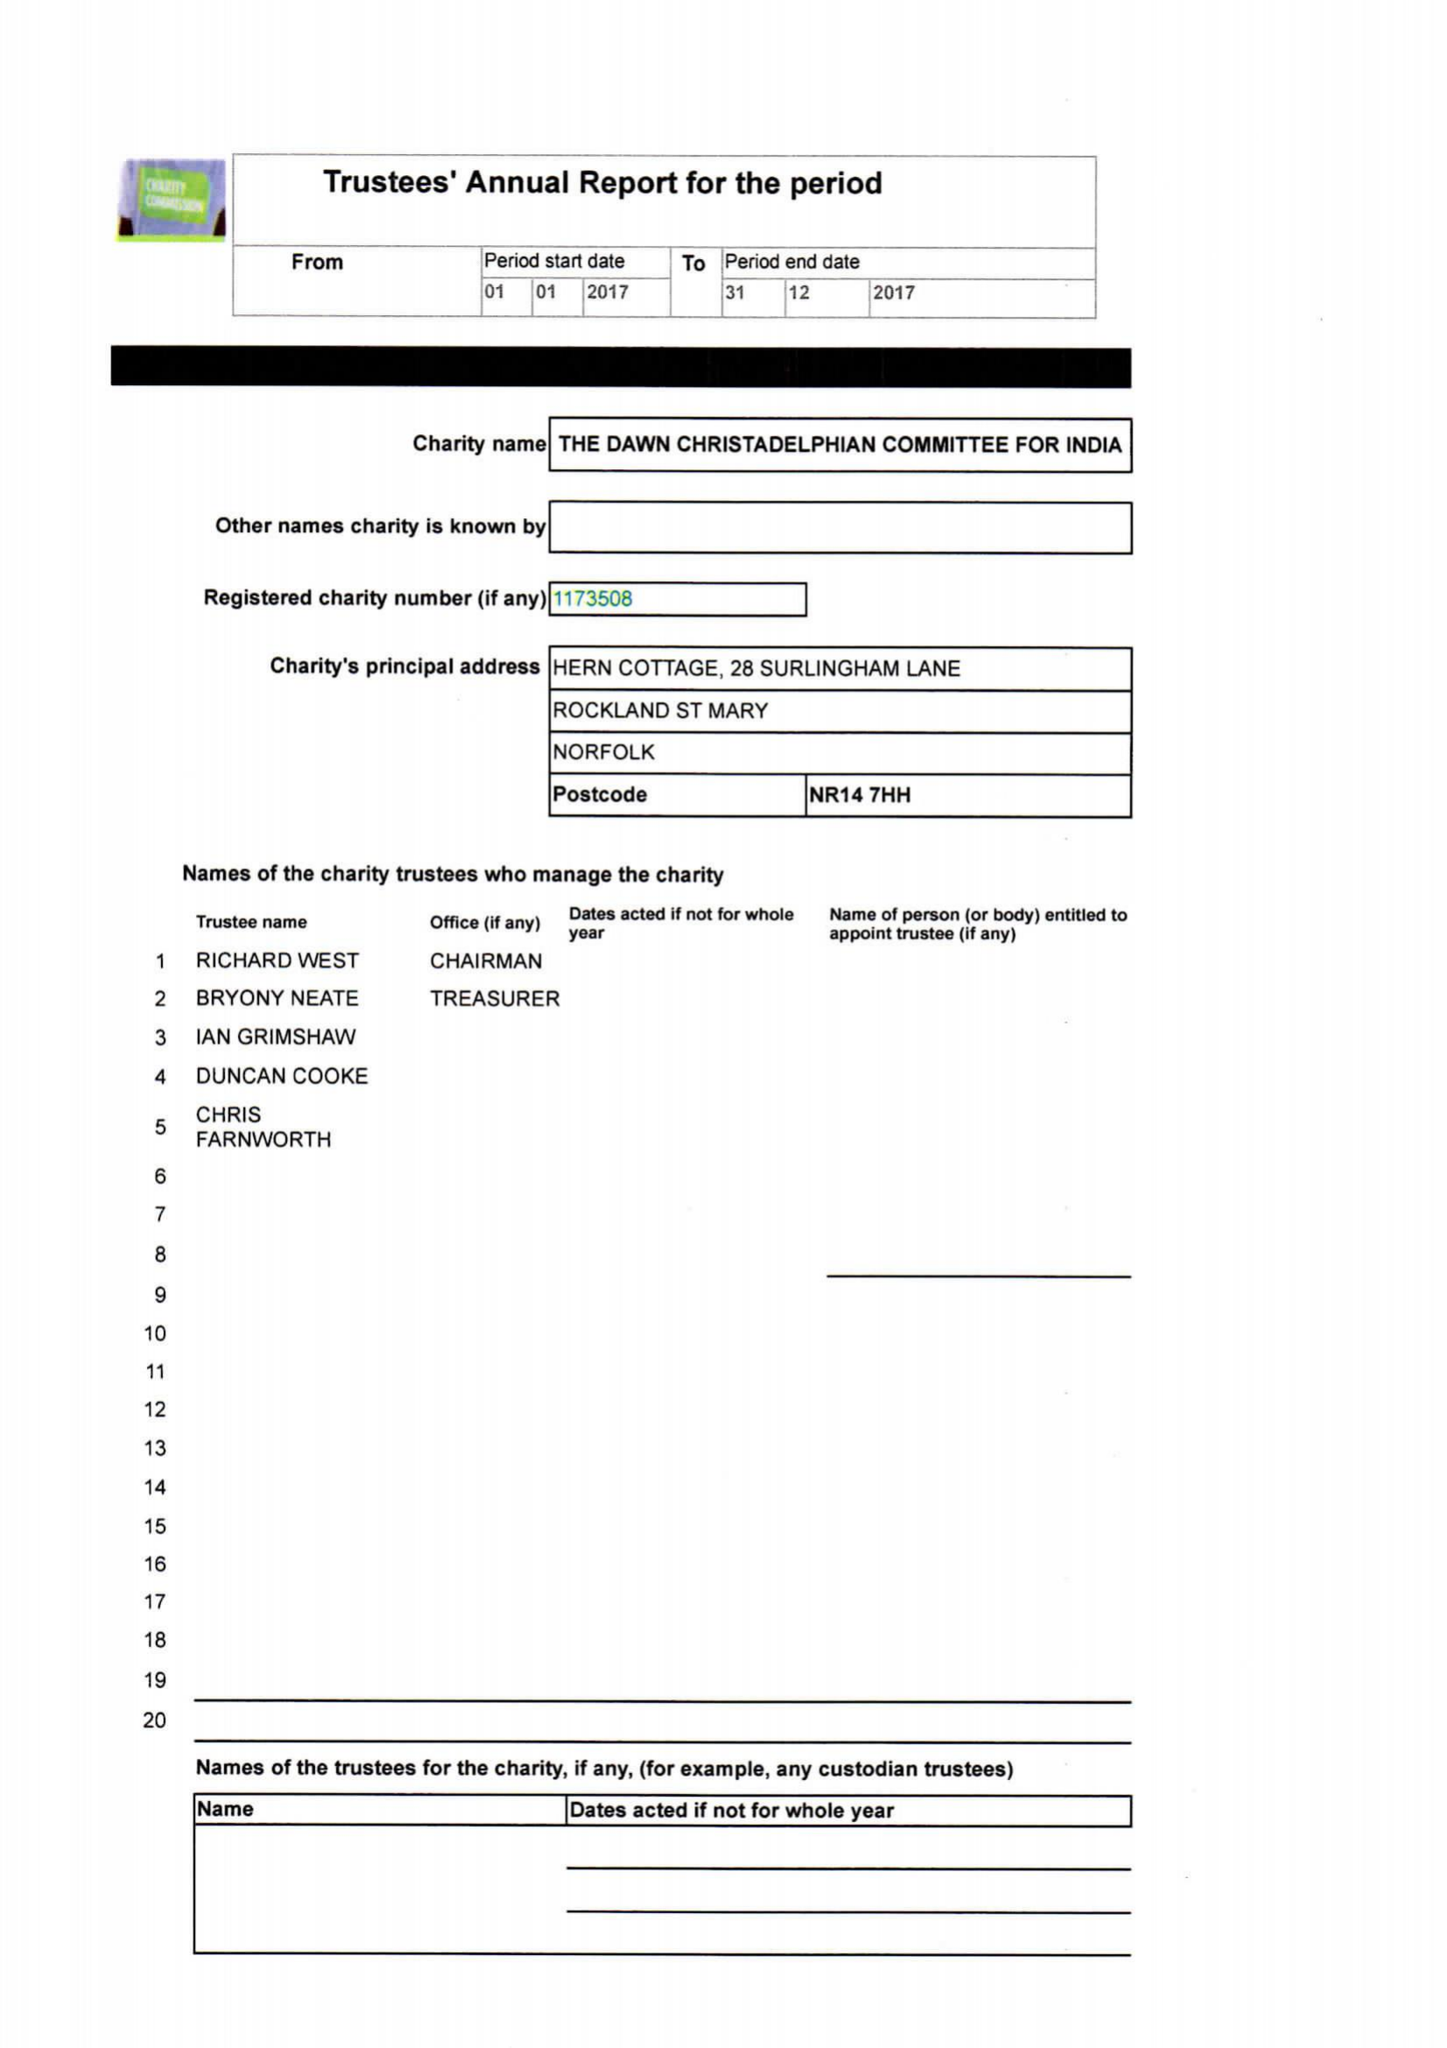What is the value for the address__street_line?
Answer the question using a single word or phrase. 28 SURLINGHAM LANE 